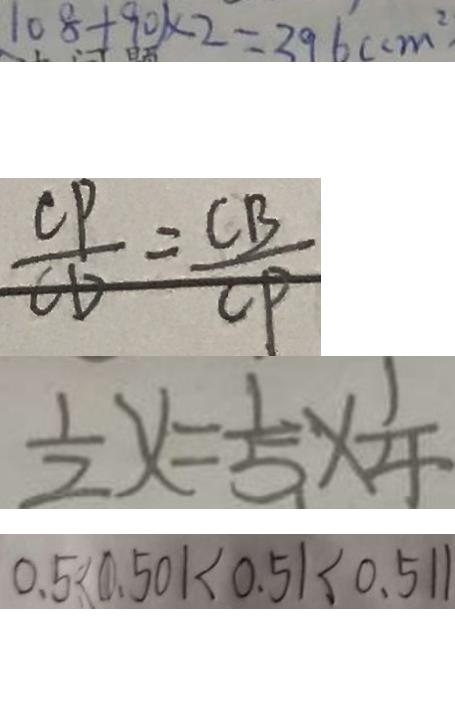<formula> <loc_0><loc_0><loc_500><loc_500>1 0 8 + 9 0 ) \times 2 = 3 9 6 ( c m ^ { 2 } 
 \frac { C P } { C D } = \frac { C B } { C P } 
 \frac { 1 } { 2 } x = \frac { 1 } { 5 } \times \frac { 1 } { 4 } 
 0 . 5 < 0 . 5 0 1 < 0 . 5 1 < 0 . 5 1 1</formula> 